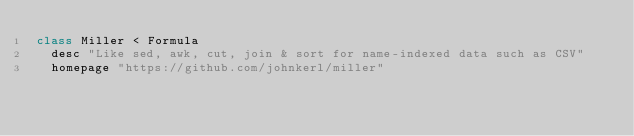Convert code to text. <code><loc_0><loc_0><loc_500><loc_500><_Ruby_>class Miller < Formula
  desc "Like sed, awk, cut, join & sort for name-indexed data such as CSV"
  homepage "https://github.com/johnkerl/miller"</code> 